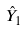Convert formula to latex. <formula><loc_0><loc_0><loc_500><loc_500>\hat { Y } _ { 1 }</formula> 